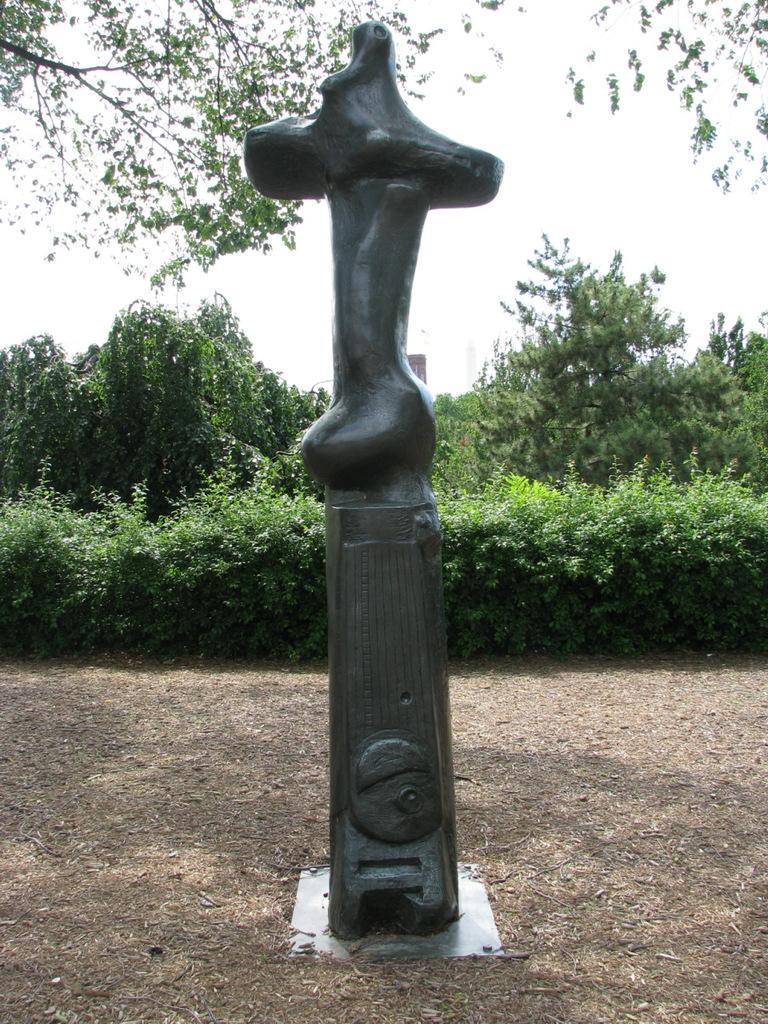Describe this image in one or two sentences. In the image we can see there is a statue which is uncertain and behind there are lot of trees and there is a clear sky. The statue is on the ground. 